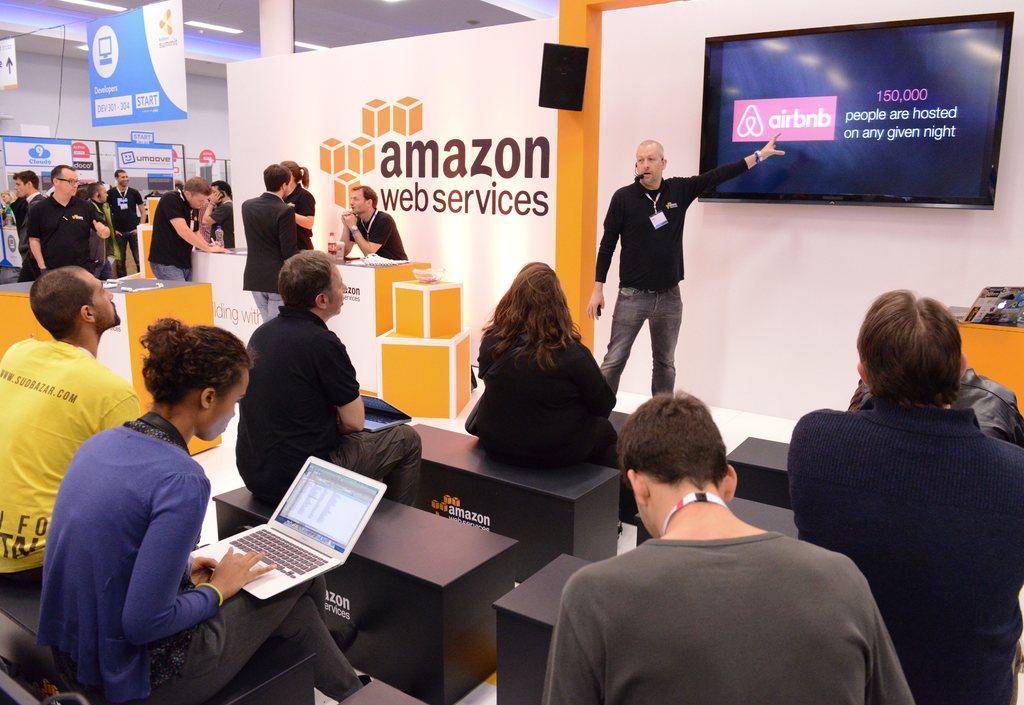Describe this image in one or two sentences. In this image we can see group of persons sitting on chairs. One person is operating a laptop. To the right side of the image we can see a person standing. To the left side of the image we can see some people standing some bottles are placed on the table. In the background, we can see a screen on the wall with some text, a laptop on the table, banners with some text and some lights. 